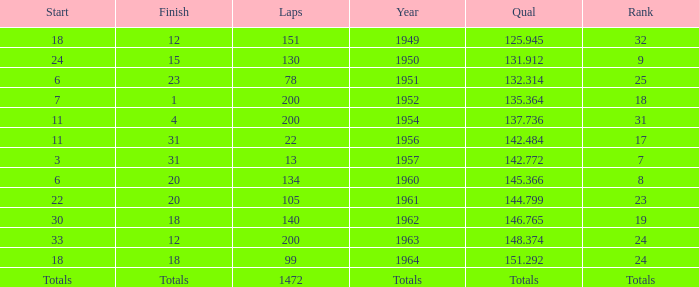Name the rank for laps less than 130 and year of 1951 25.0. 